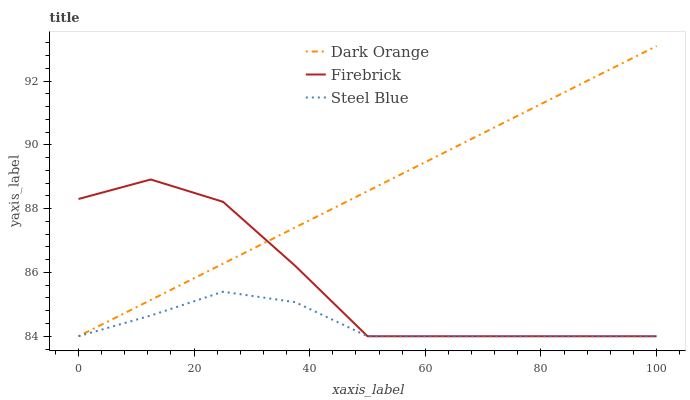Does Firebrick have the minimum area under the curve?
Answer yes or no. No. Does Firebrick have the maximum area under the curve?
Answer yes or no. No. Is Steel Blue the smoothest?
Answer yes or no. No. Is Steel Blue the roughest?
Answer yes or no. No. Does Firebrick have the highest value?
Answer yes or no. No. 